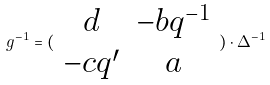Convert formula to latex. <formula><loc_0><loc_0><loc_500><loc_500>g ^ { - 1 } = ( \begin{array} { c c } d & - b q ^ { - 1 } \\ - c q ^ { \prime } & a \end{array} ) \cdot \Delta ^ { - 1 }</formula> 